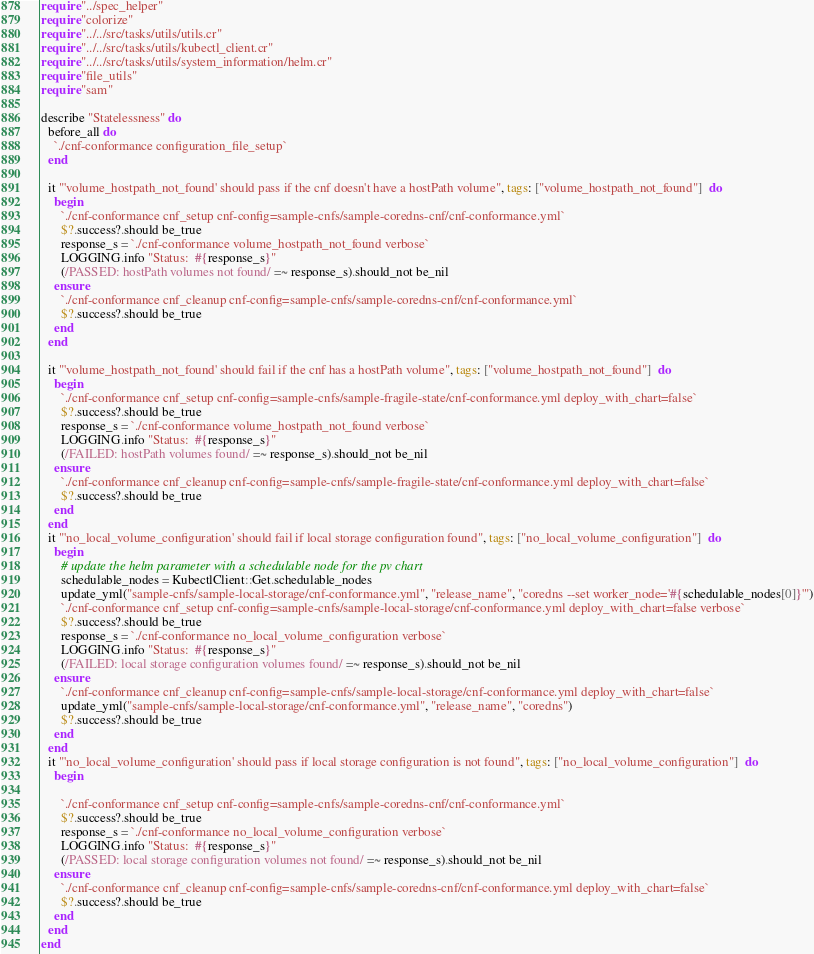Convert code to text. <code><loc_0><loc_0><loc_500><loc_500><_Crystal_>require "../spec_helper"
require "colorize"
require "../../src/tasks/utils/utils.cr"
require "../../src/tasks/utils/kubectl_client.cr"
require "../../src/tasks/utils/system_information/helm.cr"
require "file_utils"
require "sam"

describe "Statelessness" do
  before_all do
    `./cnf-conformance configuration_file_setup`
  end

  it "'volume_hostpath_not_found' should pass if the cnf doesn't have a hostPath volume", tags: ["volume_hostpath_not_found"]  do
    begin
      `./cnf-conformance cnf_setup cnf-config=sample-cnfs/sample-coredns-cnf/cnf-conformance.yml`
      $?.success?.should be_true
      response_s = `./cnf-conformance volume_hostpath_not_found verbose`
      LOGGING.info "Status:  #{response_s}"
      (/PASSED: hostPath volumes not found/ =~ response_s).should_not be_nil
    ensure
      `./cnf-conformance cnf_cleanup cnf-config=sample-cnfs/sample-coredns-cnf/cnf-conformance.yml`
      $?.success?.should be_true
    end
  end

  it "'volume_hostpath_not_found' should fail if the cnf has a hostPath volume", tags: ["volume_hostpath_not_found"]  do
    begin
      `./cnf-conformance cnf_setup cnf-config=sample-cnfs/sample-fragile-state/cnf-conformance.yml deploy_with_chart=false`
      $?.success?.should be_true
      response_s = `./cnf-conformance volume_hostpath_not_found verbose`
      LOGGING.info "Status:  #{response_s}"
      (/FAILED: hostPath volumes found/ =~ response_s).should_not be_nil
    ensure
      `./cnf-conformance cnf_cleanup cnf-config=sample-cnfs/sample-fragile-state/cnf-conformance.yml deploy_with_chart=false`
      $?.success?.should be_true
    end
  end
  it "'no_local_volume_configuration' should fail if local storage configuration found", tags: ["no_local_volume_configuration"]  do
    begin
      # update the helm parameter with a schedulable node for the pv chart
      schedulable_nodes = KubectlClient::Get.schedulable_nodes
      update_yml("sample-cnfs/sample-local-storage/cnf-conformance.yml", "release_name", "coredns --set worker_node='#{schedulable_nodes[0]}'")
      `./cnf-conformance cnf_setup cnf-config=sample-cnfs/sample-local-storage/cnf-conformance.yml deploy_with_chart=false verbose`
      $?.success?.should be_true
      response_s = `./cnf-conformance no_local_volume_configuration verbose`
      LOGGING.info "Status:  #{response_s}"
      (/FAILED: local storage configuration volumes found/ =~ response_s).should_not be_nil
    ensure
      `./cnf-conformance cnf_cleanup cnf-config=sample-cnfs/sample-local-storage/cnf-conformance.yml deploy_with_chart=false`
      update_yml("sample-cnfs/sample-local-storage/cnf-conformance.yml", "release_name", "coredns")
      $?.success?.should be_true
    end
  end
  it "'no_local_volume_configuration' should pass if local storage configuration is not found", tags: ["no_local_volume_configuration"]  do
    begin

      `./cnf-conformance cnf_setup cnf-config=sample-cnfs/sample-coredns-cnf/cnf-conformance.yml`
      $?.success?.should be_true
      response_s = `./cnf-conformance no_local_volume_configuration verbose`
      LOGGING.info "Status:  #{response_s}"
      (/PASSED: local storage configuration volumes not found/ =~ response_s).should_not be_nil
    ensure
      `./cnf-conformance cnf_cleanup cnf-config=sample-cnfs/sample-coredns-cnf/cnf-conformance.yml deploy_with_chart=false`
      $?.success?.should be_true
    end
  end
end
</code> 